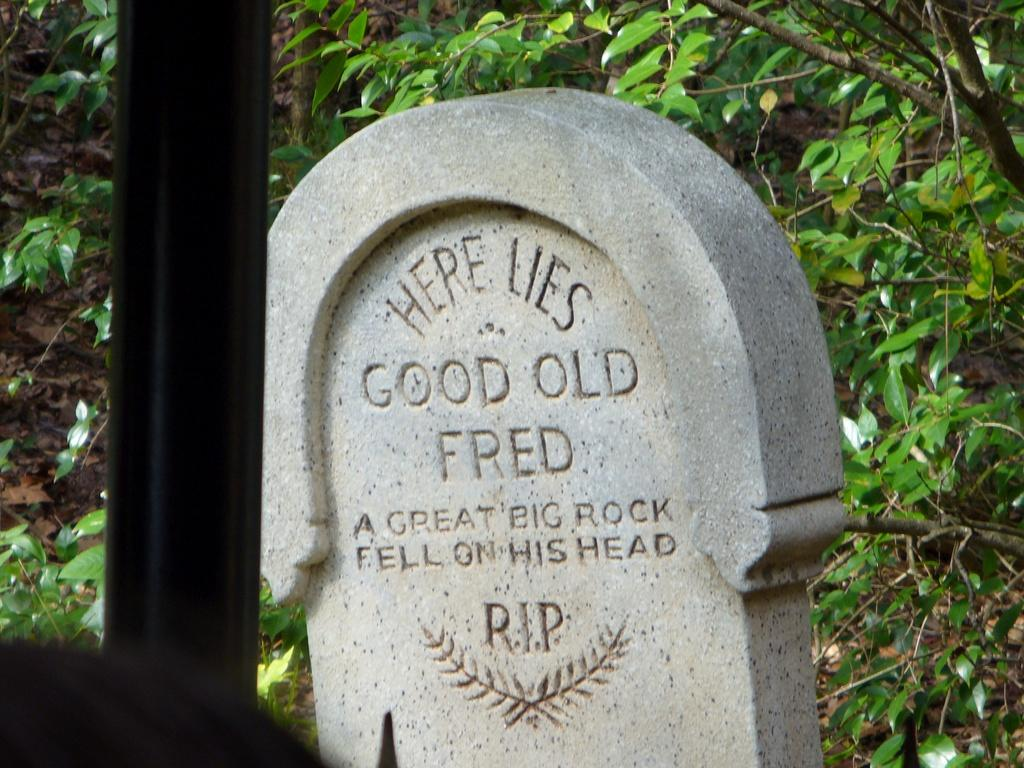What is the main object in the picture? There is a headstone in the picture. What can be found on the headstone? The headstone has something written on it. What is located behind the headstone? There are plants behind the headstone. What type of ray can be seen swimming near the headstone in the image? There is no ray present in the image; it is a headstone surrounded by plants. 